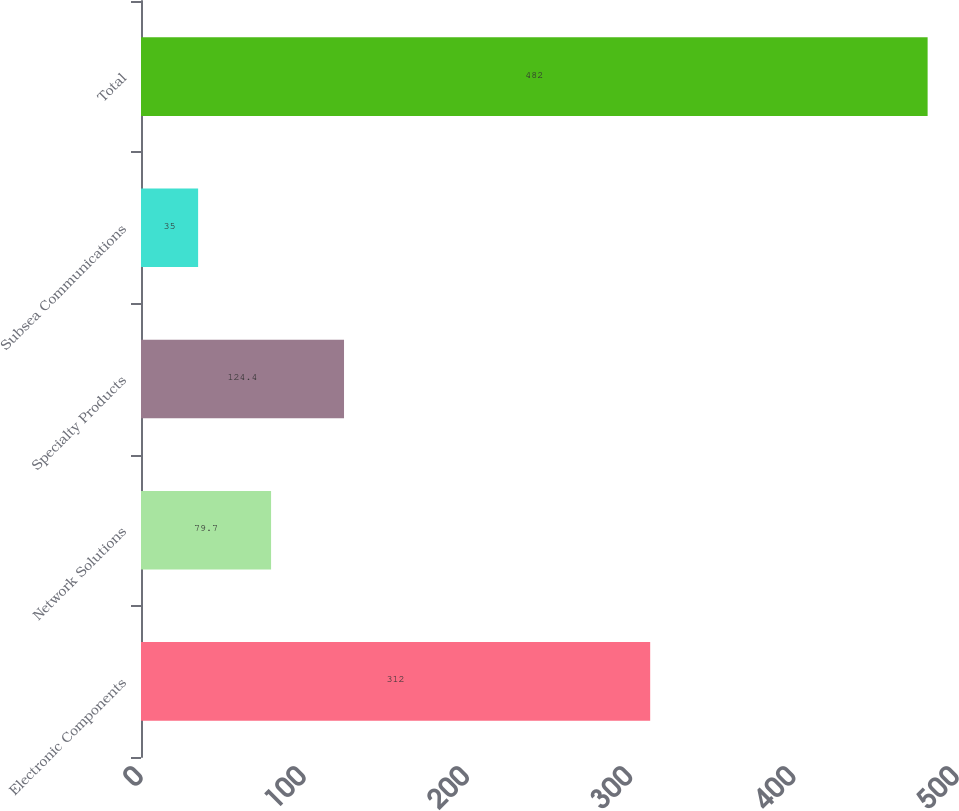Convert chart to OTSL. <chart><loc_0><loc_0><loc_500><loc_500><bar_chart><fcel>Electronic Components<fcel>Network Solutions<fcel>Specialty Products<fcel>Subsea Communications<fcel>Total<nl><fcel>312<fcel>79.7<fcel>124.4<fcel>35<fcel>482<nl></chart> 